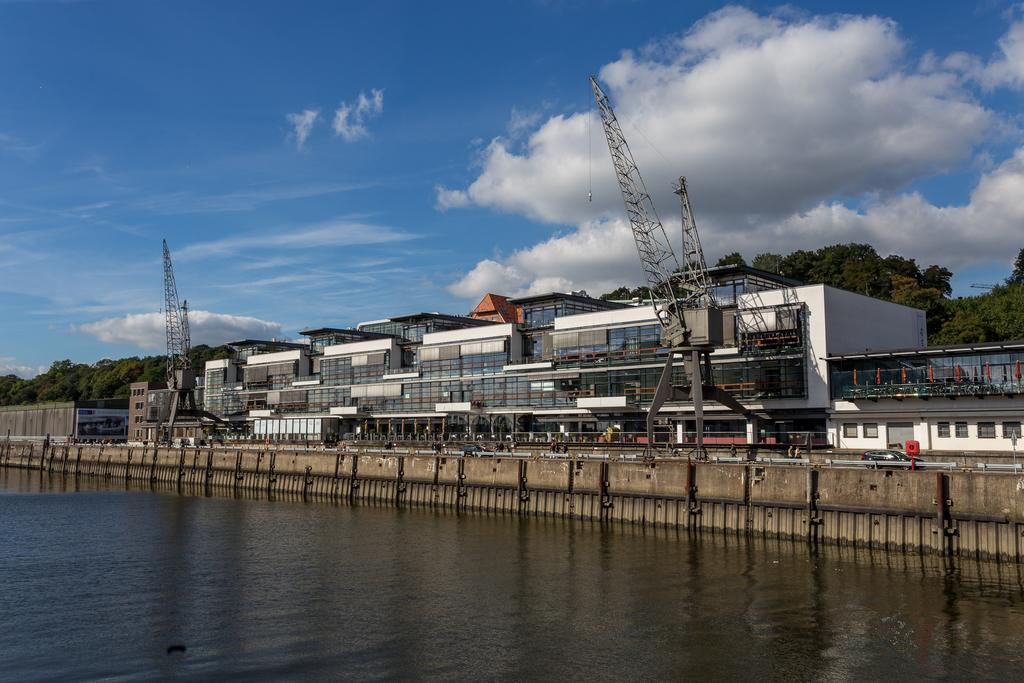What is located at the bottom side of the image? There is water at the bottom side of the image. What can be seen in the center of the image? There are trees and buildings in the center of the image. What is visible at the top side of the image? There is sky at the top side of the image. Are there any pieces of furniture visible in the image? No, there are no pieces of furniture present in the image. Can you see any fairies flying around the trees in the image? No, there are no fairies present in the image. 